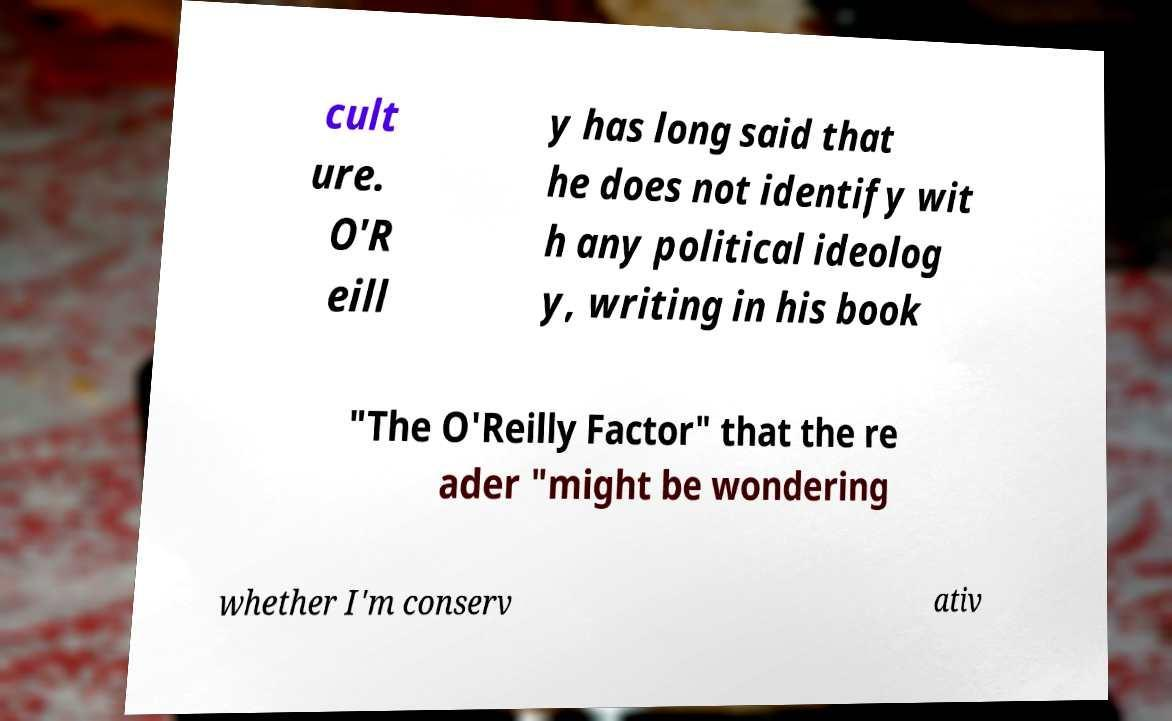I need the written content from this picture converted into text. Can you do that? cult ure. O'R eill y has long said that he does not identify wit h any political ideolog y, writing in his book "The O'Reilly Factor" that the re ader "might be wondering whether I'm conserv ativ 